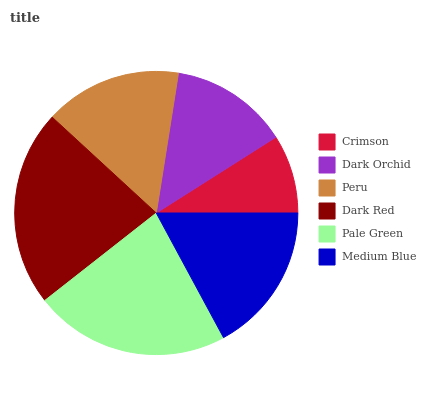Is Crimson the minimum?
Answer yes or no. Yes. Is Dark Red the maximum?
Answer yes or no. Yes. Is Dark Orchid the minimum?
Answer yes or no. No. Is Dark Orchid the maximum?
Answer yes or no. No. Is Dark Orchid greater than Crimson?
Answer yes or no. Yes. Is Crimson less than Dark Orchid?
Answer yes or no. Yes. Is Crimson greater than Dark Orchid?
Answer yes or no. No. Is Dark Orchid less than Crimson?
Answer yes or no. No. Is Medium Blue the high median?
Answer yes or no. Yes. Is Peru the low median?
Answer yes or no. Yes. Is Peru the high median?
Answer yes or no. No. Is Dark Red the low median?
Answer yes or no. No. 